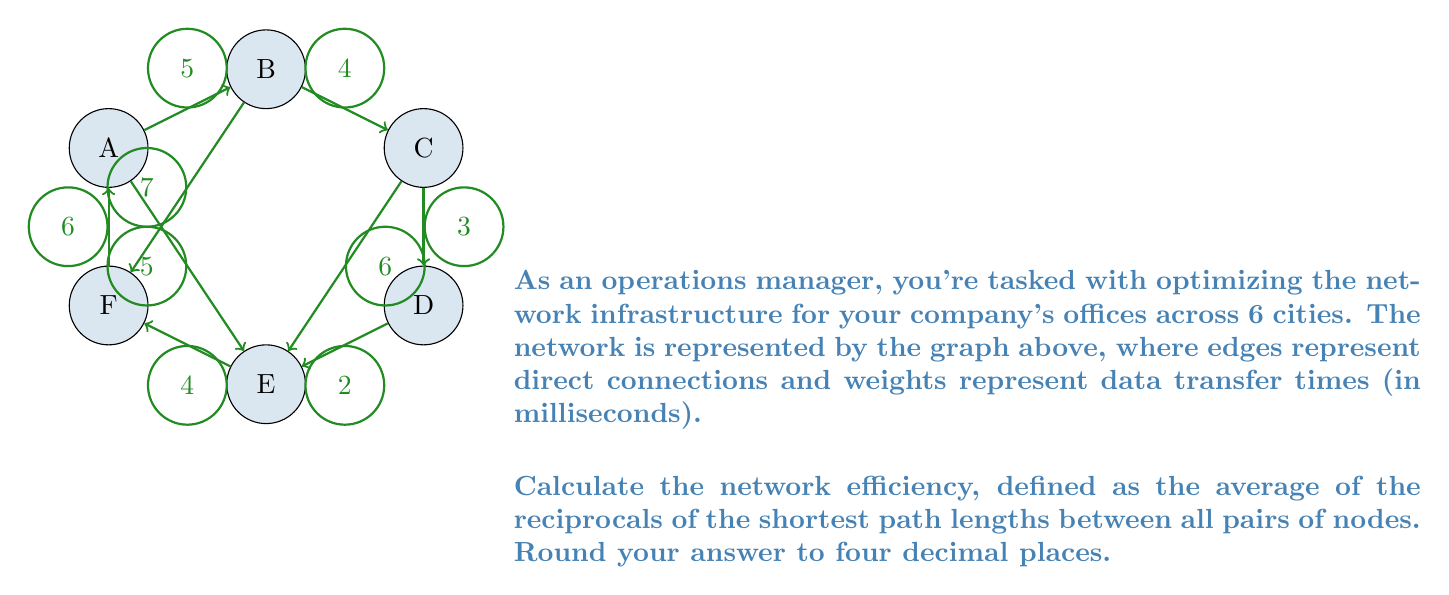Show me your answer to this math problem. To solve this problem, we'll follow these steps:

1) First, we need to find the shortest path between all pairs of nodes using Dijkstra's algorithm or Floyd-Warshall algorithm.

2) Then, we'll calculate the reciprocal of each shortest path length.

3) Finally, we'll take the average of all these reciprocals.

Let's start:

1) Shortest path matrix (using Floyd-Warshall algorithm):

$$
\begin{matrix}
  & A & B & C & D & E & F \\
A & 0 & 5 & 9 & 12 & 5 & 6 \\
B & 5 & 0 & 4 & 7 & 9 & 7 \\
C & 9 & 4 & 0 & 3 & 6 & 10 \\
D & 12 & 7 & 3 & 0 & 2 & 6 \\
E & 5 & 9 & 6 & 2 & 0 & 4 \\
F & 6 & 7 & 10 & 6 & 4 & 0
\end{matrix}
$$

2) Reciprocal matrix:

$$
\begin{matrix}
  & A & B & C & D & E & F \\
A & - & 1/5 & 1/9 & 1/12 & 1/5 & 1/6 \\
B & 1/5 & - & 1/4 & 1/7 & 1/9 & 1/7 \\
C & 1/9 & 1/4 & - & 1/3 & 1/6 & 1/10 \\
D & 1/12 & 1/7 & 1/3 & - & 1/2 & 1/6 \\
E & 1/5 & 1/9 & 1/6 & 1/2 & - & 1/4 \\
F & 1/6 & 1/7 & 1/10 & 1/6 & 1/4 & -
\end{matrix}
$$

3) Sum of all reciprocals (excluding diagonal):
$$(1/5 + 1/9 + 1/12 + 1/5 + 1/6 + 1/5 + 1/4 + 1/7 + 1/9 + 1/7 + 1/9 + 1/4 + 1/3 + 1/6 + 1/10 + 1/12 + 1/7 + 1/3 + 1/2 + 1/6 + 1/5 + 1/9 + 1/6 + 1/2 + 1/4 + 1/6 + 1/7 + 1/10 + 1/6 + 1/4) = 5.9738$$

4) Number of pairs: $6 * 5 = 30$

5) Average: $5.9738 / 30 = 0.1991$

Therefore, the network efficiency is approximately 0.1991.
Answer: 0.1991 